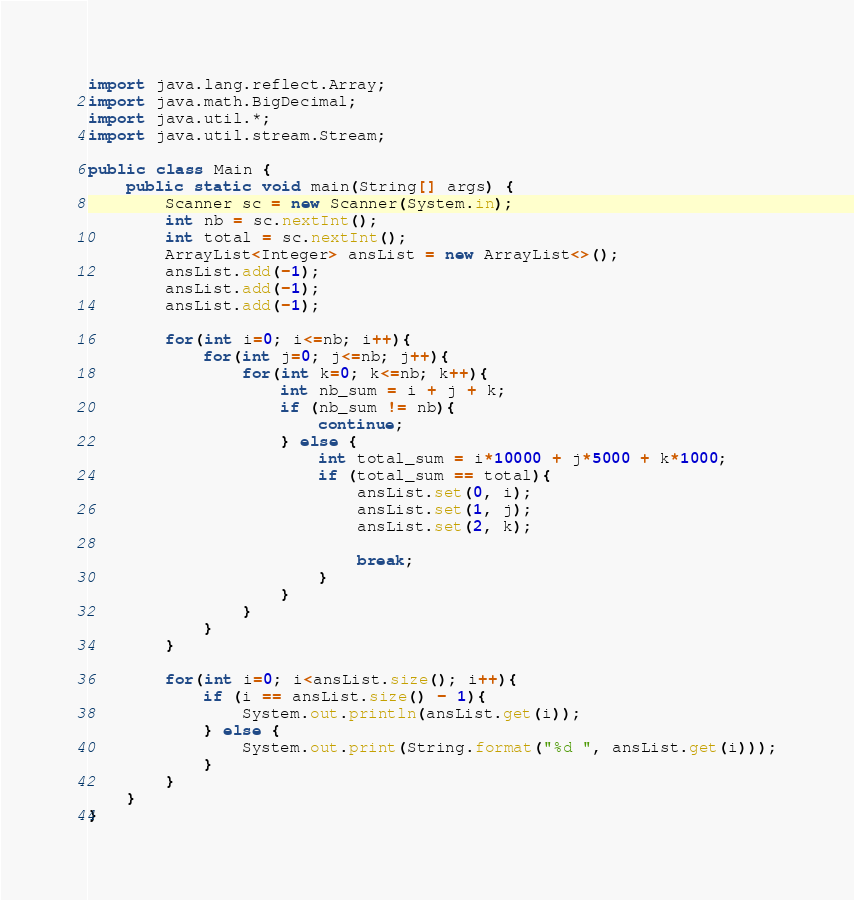<code> <loc_0><loc_0><loc_500><loc_500><_Java_>import java.lang.reflect.Array;
import java.math.BigDecimal;
import java.util.*;
import java.util.stream.Stream;

public class Main {
    public static void main(String[] args) {
        Scanner sc = new Scanner(System.in);
        int nb = sc.nextInt();
        int total = sc.nextInt();
        ArrayList<Integer> ansList = new ArrayList<>();
        ansList.add(-1);
        ansList.add(-1);
        ansList.add(-1);

        for(int i=0; i<=nb; i++){
            for(int j=0; j<=nb; j++){
                for(int k=0; k<=nb; k++){
                    int nb_sum = i + j + k;
                    if (nb_sum != nb){
                        continue;
                    } else {
                        int total_sum = i*10000 + j*5000 + k*1000;
                        if (total_sum == total){
                            ansList.set(0, i);
                            ansList.set(1, j);
                            ansList.set(2, k);

                            break;
                        }
                    }
                }
            }
        }

        for(int i=0; i<ansList.size(); i++){
            if (i == ansList.size() - 1){
                System.out.println(ansList.get(i));
            } else {
                System.out.print(String.format("%d ", ansList.get(i)));
            }
        }
    }
}
</code> 